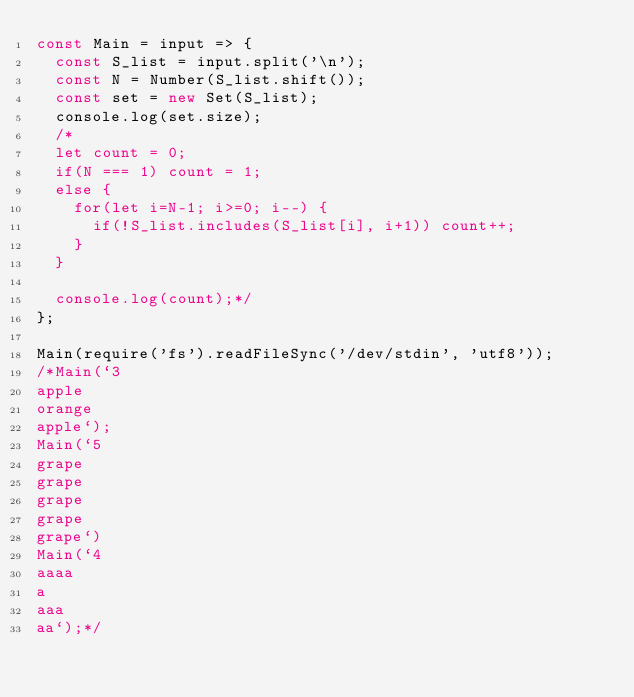Convert code to text. <code><loc_0><loc_0><loc_500><loc_500><_JavaScript_>const Main = input => {
  const S_list = input.split('\n');
  const N = Number(S_list.shift());
  const set = new Set(S_list);
  console.log(set.size);
  /*
  let count = 0;
  if(N === 1) count = 1;
  else {
    for(let i=N-1; i>=0; i--) {
      if(!S_list.includes(S_list[i], i+1)) count++;
    }
  }

  console.log(count);*/
};

Main(require('fs').readFileSync('/dev/stdin', 'utf8'));
/*Main(`3
apple
orange
apple`);
Main(`5
grape
grape
grape
grape
grape`)
Main(`4
aaaa
a
aaa
aa`);*/
</code> 